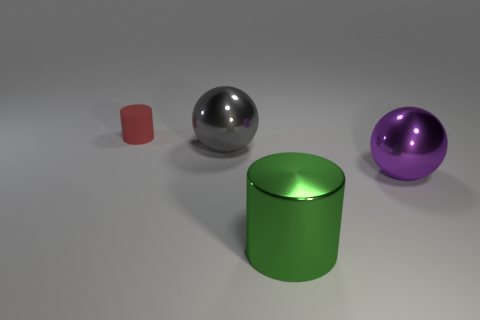Add 1 tiny objects. How many objects exist? 5 Add 4 tiny yellow matte cubes. How many tiny yellow matte cubes exist? 4 Subtract 0 purple cylinders. How many objects are left? 4 Subtract all large green things. Subtract all green metal cylinders. How many objects are left? 2 Add 2 gray objects. How many gray objects are left? 3 